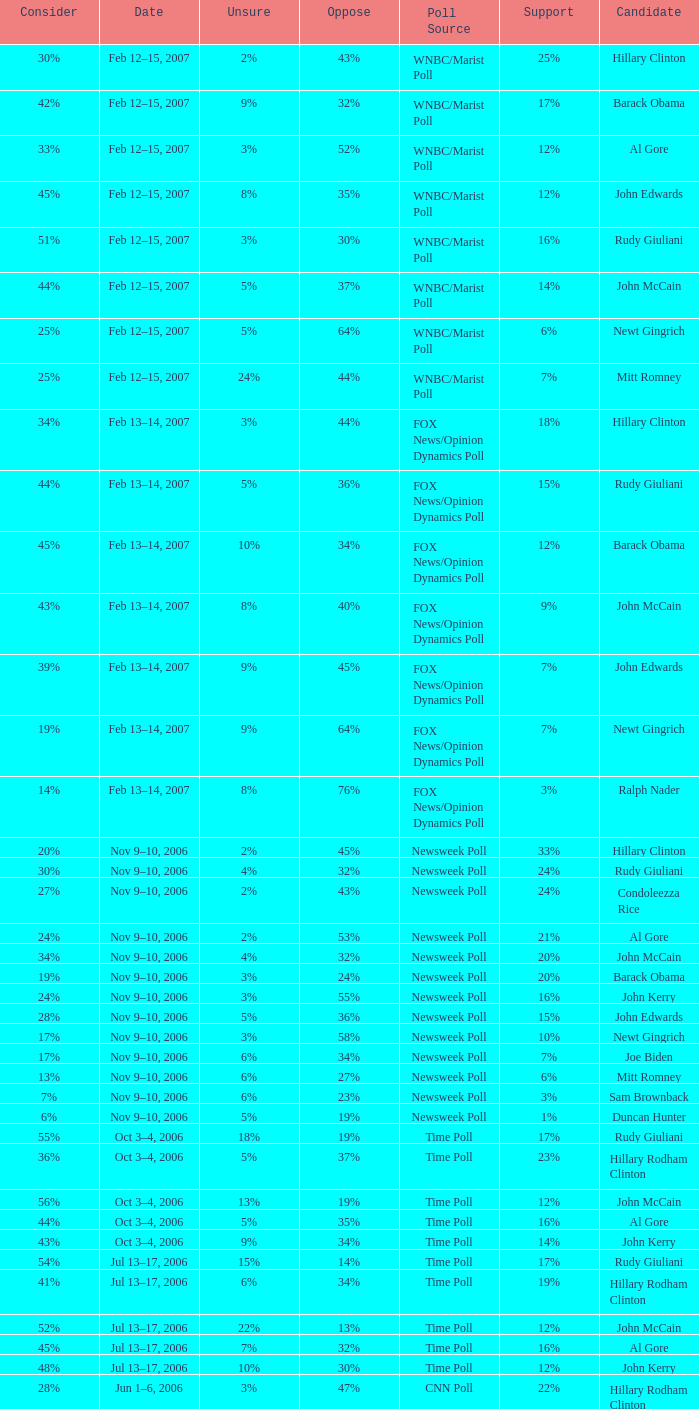What percentage of people said they would consider Rudy Giuliani as a candidate according to the Newsweek poll that showed 32% opposed him? 30%. 